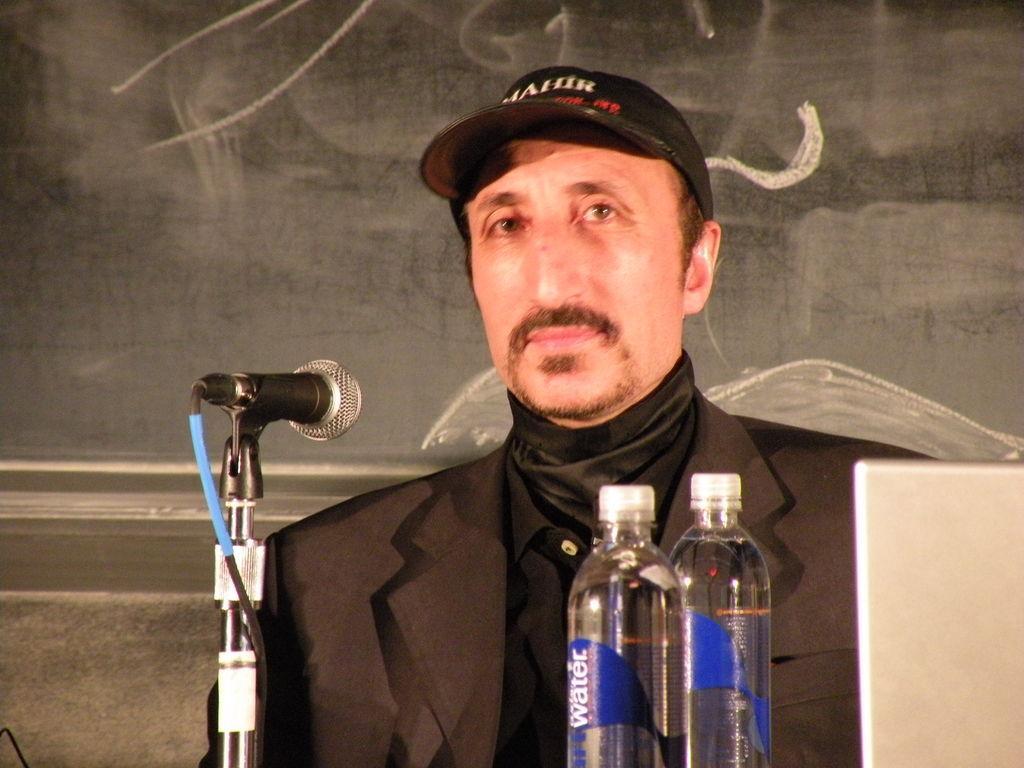Please provide a concise description of this image. In this picture we can see a man. He is in black color suit. He wear a cap and this is the mike. And there are two bottles. 